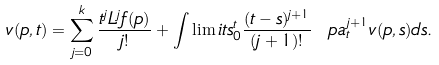Convert formula to latex. <formula><loc_0><loc_0><loc_500><loc_500>v ( p , t ) = \sum _ { j = 0 } ^ { k } \frac { t ^ { j } L ^ { j } f ( p ) } { j ! } + \int \lim i t s _ { 0 } ^ { t } \frac { ( t - s ) ^ { j + 1 } } { ( j + 1 ) ! } \ p a _ { t } ^ { j + 1 } v ( p , s ) d s .</formula> 